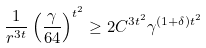<formula> <loc_0><loc_0><loc_500><loc_500>\frac { 1 } { r ^ { 3 t } } \left ( \frac { \gamma } { 6 4 } \right ) ^ { t ^ { 2 } } \geq 2 C ^ { 3 t ^ { 2 } } \gamma ^ { ( 1 + \delta ) t ^ { 2 } }</formula> 